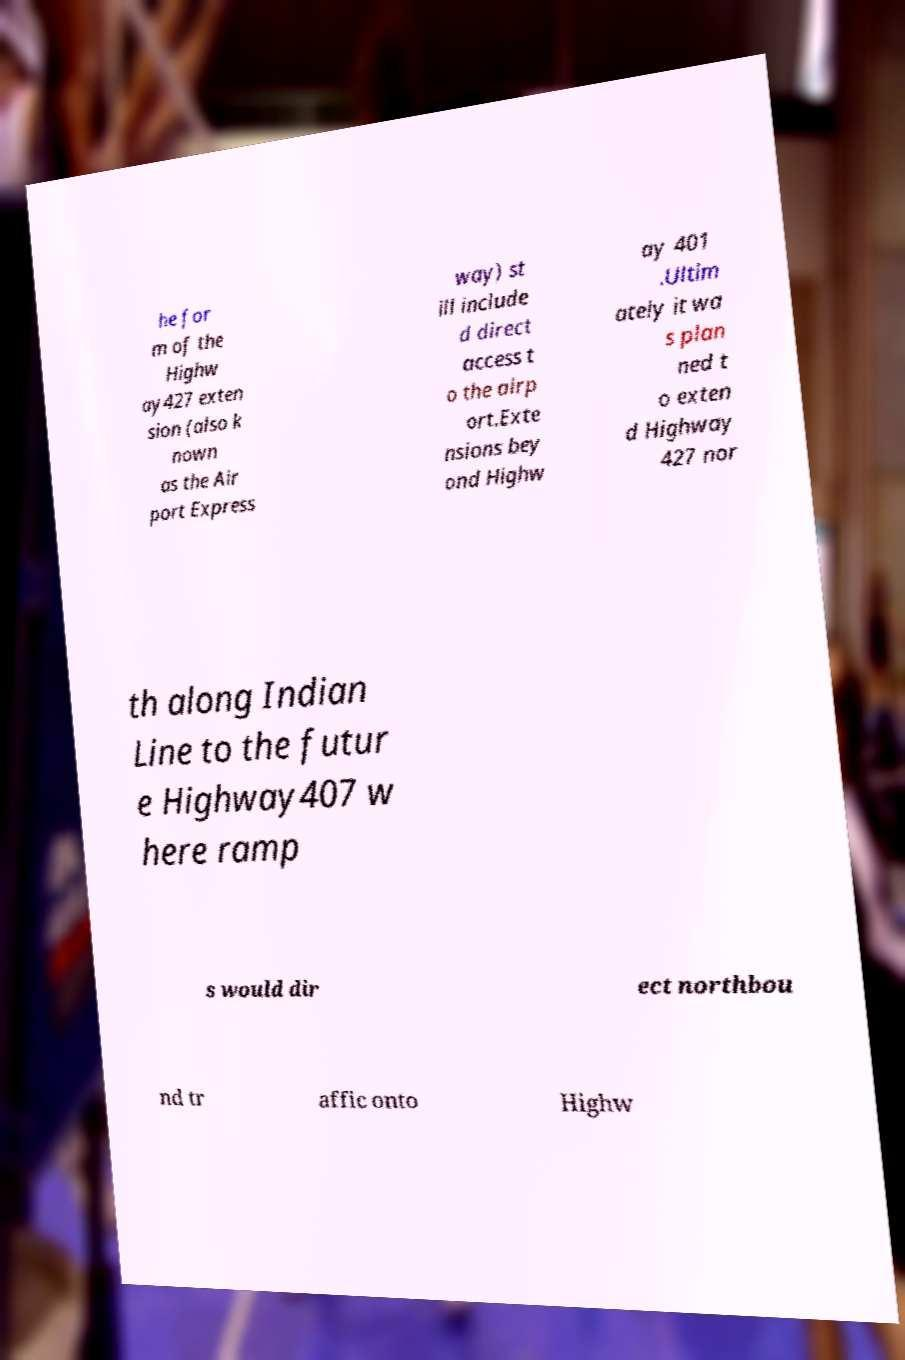For documentation purposes, I need the text within this image transcribed. Could you provide that? he for m of the Highw ay427 exten sion (also k nown as the Air port Express way) st ill include d direct access t o the airp ort.Exte nsions bey ond Highw ay 401 .Ultim ately it wa s plan ned t o exten d Highway 427 nor th along Indian Line to the futur e Highway407 w here ramp s would dir ect northbou nd tr affic onto Highw 